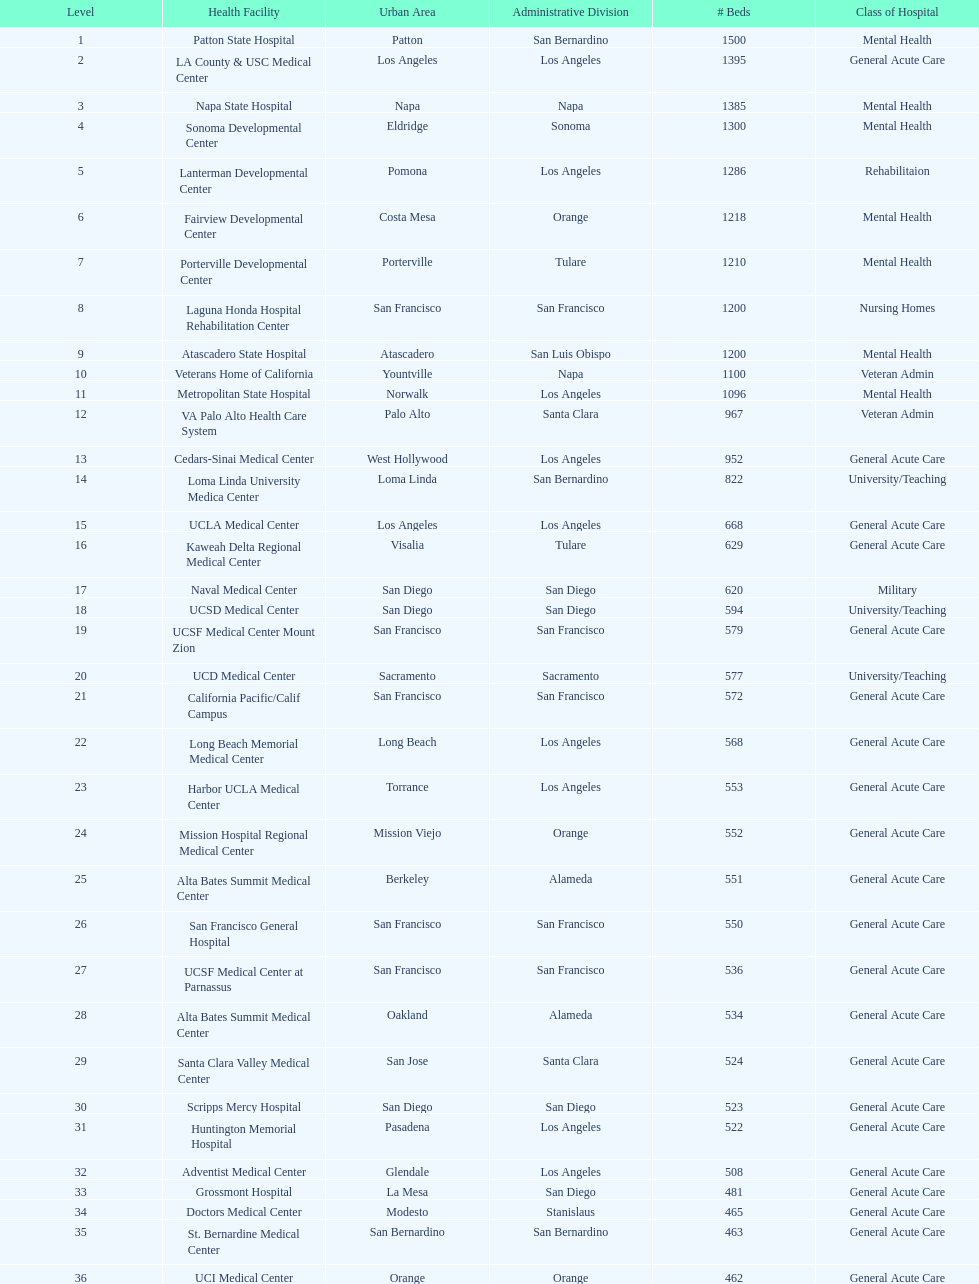Would you mind parsing the complete table? {'header': ['Level', 'Health Facility', 'Urban Area', 'Administrative Division', '# Beds', 'Class of Hospital'], 'rows': [['1', 'Patton State Hospital', 'Patton', 'San Bernardino', '1500', 'Mental Health'], ['2', 'LA County & USC Medical Center', 'Los Angeles', 'Los Angeles', '1395', 'General Acute Care'], ['3', 'Napa State Hospital', 'Napa', 'Napa', '1385', 'Mental Health'], ['4', 'Sonoma Developmental Center', 'Eldridge', 'Sonoma', '1300', 'Mental Health'], ['5', 'Lanterman Developmental Center', 'Pomona', 'Los Angeles', '1286', 'Rehabilitaion'], ['6', 'Fairview Developmental Center', 'Costa Mesa', 'Orange', '1218', 'Mental Health'], ['7', 'Porterville Developmental Center', 'Porterville', 'Tulare', '1210', 'Mental Health'], ['8', 'Laguna Honda Hospital Rehabilitation Center', 'San Francisco', 'San Francisco', '1200', 'Nursing Homes'], ['9', 'Atascadero State Hospital', 'Atascadero', 'San Luis Obispo', '1200', 'Mental Health'], ['10', 'Veterans Home of California', 'Yountville', 'Napa', '1100', 'Veteran Admin'], ['11', 'Metropolitan State Hospital', 'Norwalk', 'Los Angeles', '1096', 'Mental Health'], ['12', 'VA Palo Alto Health Care System', 'Palo Alto', 'Santa Clara', '967', 'Veteran Admin'], ['13', 'Cedars-Sinai Medical Center', 'West Hollywood', 'Los Angeles', '952', 'General Acute Care'], ['14', 'Loma Linda University Medica Center', 'Loma Linda', 'San Bernardino', '822', 'University/Teaching'], ['15', 'UCLA Medical Center', 'Los Angeles', 'Los Angeles', '668', 'General Acute Care'], ['16', 'Kaweah Delta Regional Medical Center', 'Visalia', 'Tulare', '629', 'General Acute Care'], ['17', 'Naval Medical Center', 'San Diego', 'San Diego', '620', 'Military'], ['18', 'UCSD Medical Center', 'San Diego', 'San Diego', '594', 'University/Teaching'], ['19', 'UCSF Medical Center Mount Zion', 'San Francisco', 'San Francisco', '579', 'General Acute Care'], ['20', 'UCD Medical Center', 'Sacramento', 'Sacramento', '577', 'University/Teaching'], ['21', 'California Pacific/Calif Campus', 'San Francisco', 'San Francisco', '572', 'General Acute Care'], ['22', 'Long Beach Memorial Medical Center', 'Long Beach', 'Los Angeles', '568', 'General Acute Care'], ['23', 'Harbor UCLA Medical Center', 'Torrance', 'Los Angeles', '553', 'General Acute Care'], ['24', 'Mission Hospital Regional Medical Center', 'Mission Viejo', 'Orange', '552', 'General Acute Care'], ['25', 'Alta Bates Summit Medical Center', 'Berkeley', 'Alameda', '551', 'General Acute Care'], ['26', 'San Francisco General Hospital', 'San Francisco', 'San Francisco', '550', 'General Acute Care'], ['27', 'UCSF Medical Center at Parnassus', 'San Francisco', 'San Francisco', '536', 'General Acute Care'], ['28', 'Alta Bates Summit Medical Center', 'Oakland', 'Alameda', '534', 'General Acute Care'], ['29', 'Santa Clara Valley Medical Center', 'San Jose', 'Santa Clara', '524', 'General Acute Care'], ['30', 'Scripps Mercy Hospital', 'San Diego', 'San Diego', '523', 'General Acute Care'], ['31', 'Huntington Memorial Hospital', 'Pasadena', 'Los Angeles', '522', 'General Acute Care'], ['32', 'Adventist Medical Center', 'Glendale', 'Los Angeles', '508', 'General Acute Care'], ['33', 'Grossmont Hospital', 'La Mesa', 'San Diego', '481', 'General Acute Care'], ['34', 'Doctors Medical Center', 'Modesto', 'Stanislaus', '465', 'General Acute Care'], ['35', 'St. Bernardine Medical Center', 'San Bernardino', 'San Bernardino', '463', 'General Acute Care'], ['36', 'UCI Medical Center', 'Orange', 'Orange', '462', 'General Acute Care'], ['37', 'Stanford Medical Center', 'Stanford', 'Santa Clara', '460', 'General Acute Care'], ['38', 'Community Regional Medical Center', 'Fresno', 'Fresno', '457', 'General Acute Care'], ['39', 'Methodist Hospital', 'Arcadia', 'Los Angeles', '455', 'General Acute Care'], ['40', 'Providence St. Joseph Medical Center', 'Burbank', 'Los Angeles', '455', 'General Acute Care'], ['41', 'Hoag Memorial Hospital', 'Newport Beach', 'Orange', '450', 'General Acute Care'], ['42', 'Agnews Developmental Center', 'San Jose', 'Santa Clara', '450', 'Mental Health'], ['43', 'Jewish Home', 'San Francisco', 'San Francisco', '450', 'Nursing Homes'], ['44', 'St. Joseph Hospital Orange', 'Orange', 'Orange', '448', 'General Acute Care'], ['45', 'Presbyterian Intercommunity', 'Whittier', 'Los Angeles', '441', 'General Acute Care'], ['46', 'Kaiser Permanente Medical Center', 'Fontana', 'San Bernardino', '440', 'General Acute Care'], ['47', 'Kaiser Permanente Medical Center', 'Los Angeles', 'Los Angeles', '439', 'General Acute Care'], ['48', 'Pomona Valley Hospital Medical Center', 'Pomona', 'Los Angeles', '436', 'General Acute Care'], ['49', 'Sutter General Medical Center', 'Sacramento', 'Sacramento', '432', 'General Acute Care'], ['50', 'St. Mary Medical Center', 'San Francisco', 'San Francisco', '430', 'General Acute Care'], ['50', 'Good Samaritan Hospital', 'San Jose', 'Santa Clara', '429', 'General Acute Care']]} How much larger (in number of beds) was the largest hospital in california than the 50th largest? 1071. 